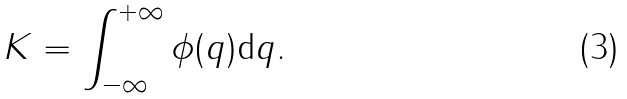<formula> <loc_0><loc_0><loc_500><loc_500>K = \int _ { - \infty } ^ { + \infty } \phi ( q ) { \mbox d } q .</formula> 